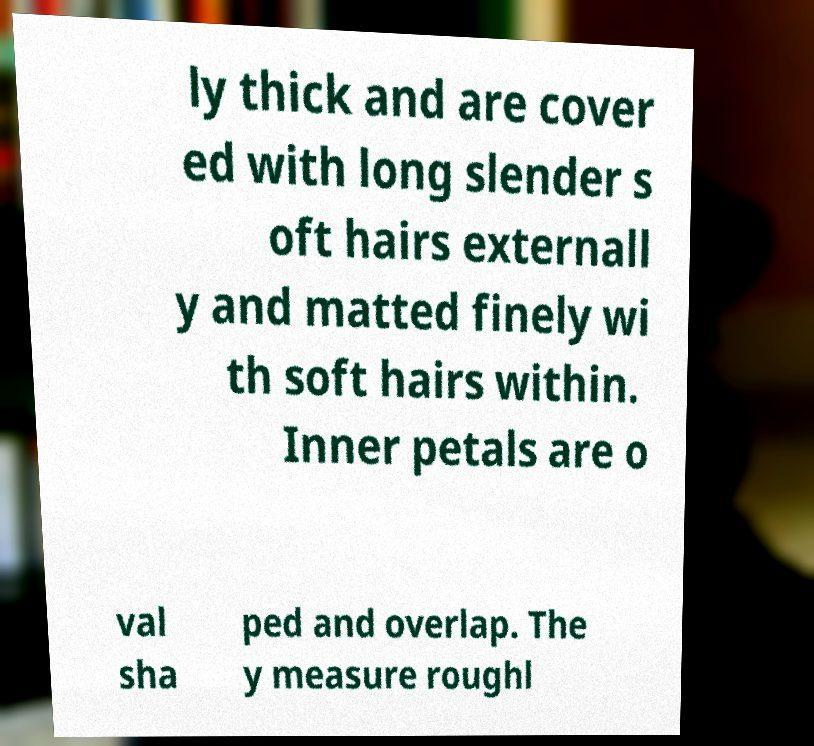I need the written content from this picture converted into text. Can you do that? ly thick and are cover ed with long slender s oft hairs externall y and matted finely wi th soft hairs within. Inner petals are o val sha ped and overlap. The y measure roughl 